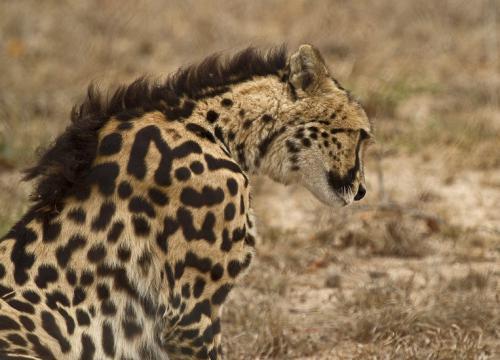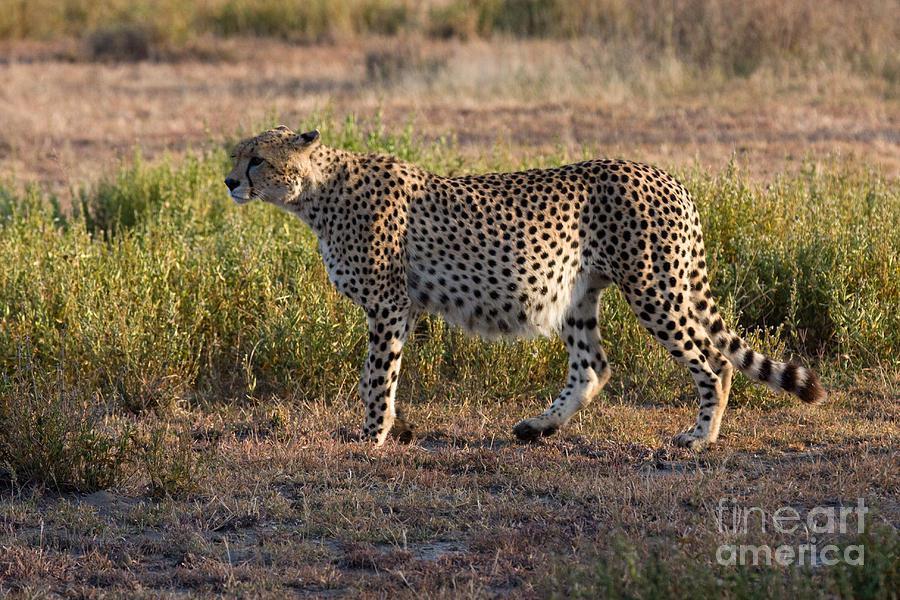The first image is the image on the left, the second image is the image on the right. For the images shown, is this caption "The left image shows a close-mouthed cheetah with a ridge of dark hair running from its head like a mane and its body in profile." true? Answer yes or no. Yes. The first image is the image on the left, the second image is the image on the right. Given the left and right images, does the statement "There are two animals in total." hold true? Answer yes or no. Yes. 